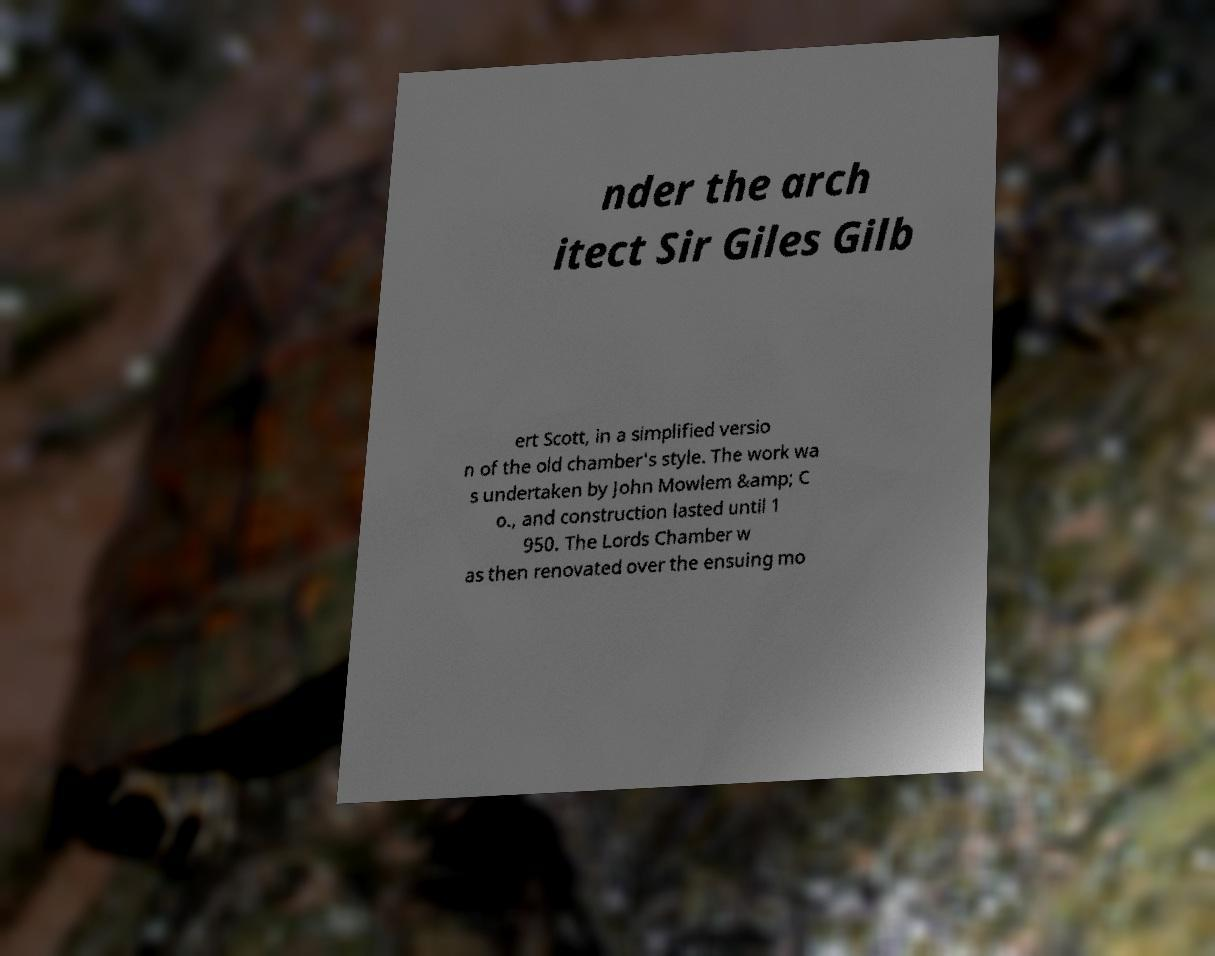For documentation purposes, I need the text within this image transcribed. Could you provide that? nder the arch itect Sir Giles Gilb ert Scott, in a simplified versio n of the old chamber's style. The work wa s undertaken by John Mowlem &amp; C o., and construction lasted until 1 950. The Lords Chamber w as then renovated over the ensuing mo 